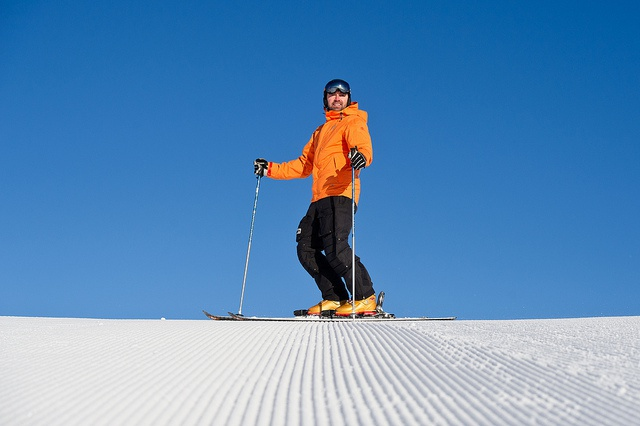Describe the objects in this image and their specific colors. I can see people in blue, black, orange, red, and gray tones and skis in blue, white, gray, and darkgray tones in this image. 